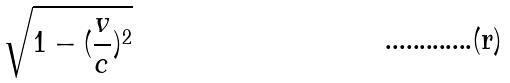<formula> <loc_0><loc_0><loc_500><loc_500>\sqrt { 1 - ( \frac { v } { c } ) ^ { 2 } }</formula> 